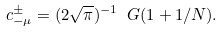Convert formula to latex. <formula><loc_0><loc_0><loc_500><loc_500>c _ { - \mu } ^ { \pm } = ( 2 \sqrt { \pi } ) ^ { - 1 } \ G ( 1 + 1 / N ) .</formula> 